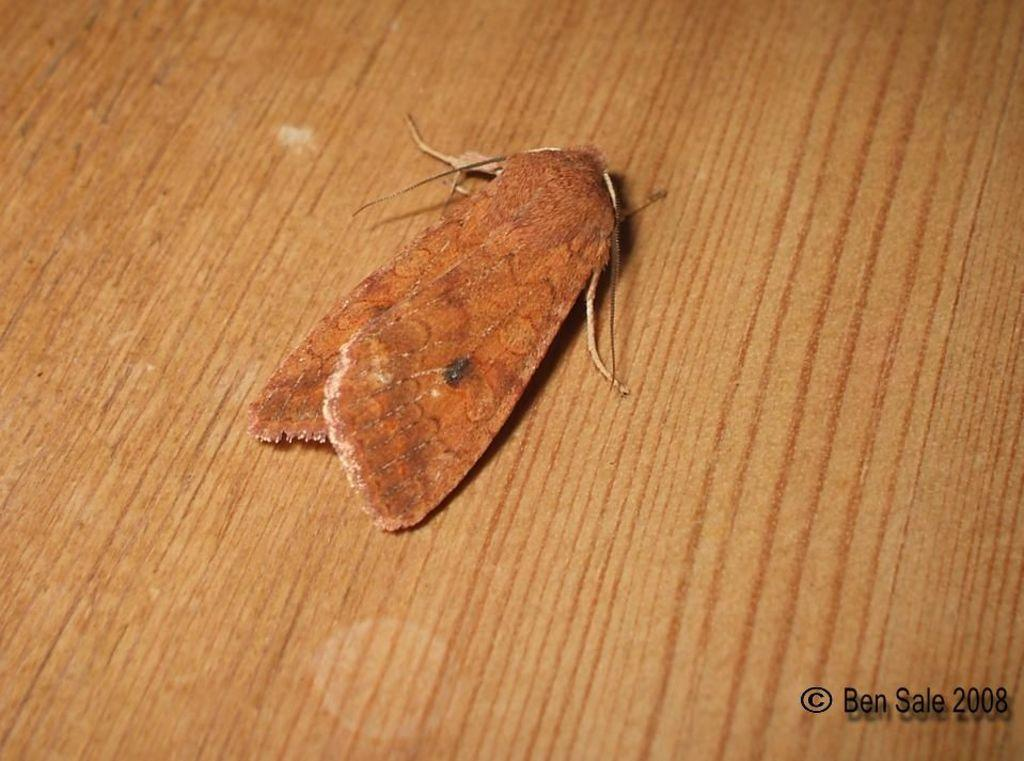What type of insect is present in the image? There is a moth in the image. What shape is the moth's voyage taking in the image? There is no indication of a voyage or a specific shape in the image, as it simply features a moth. 